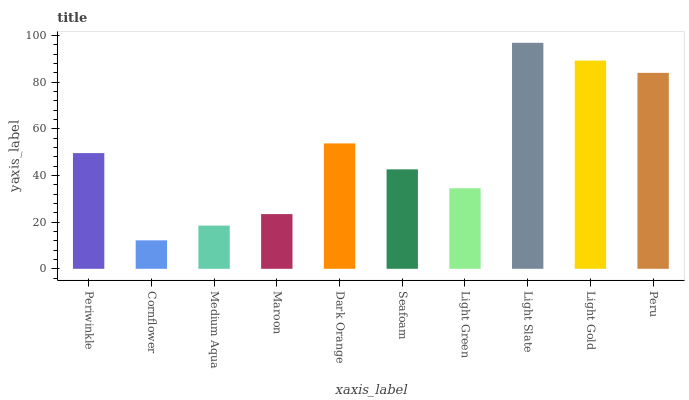Is Cornflower the minimum?
Answer yes or no. Yes. Is Light Slate the maximum?
Answer yes or no. Yes. Is Medium Aqua the minimum?
Answer yes or no. No. Is Medium Aqua the maximum?
Answer yes or no. No. Is Medium Aqua greater than Cornflower?
Answer yes or no. Yes. Is Cornflower less than Medium Aqua?
Answer yes or no. Yes. Is Cornflower greater than Medium Aqua?
Answer yes or no. No. Is Medium Aqua less than Cornflower?
Answer yes or no. No. Is Periwinkle the high median?
Answer yes or no. Yes. Is Seafoam the low median?
Answer yes or no. Yes. Is Dark Orange the high median?
Answer yes or no. No. Is Light Slate the low median?
Answer yes or no. No. 